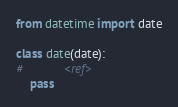<code> <loc_0><loc_0><loc_500><loc_500><_Python_>from datetime import date

class date(date):
#            <ref>
    pass</code> 